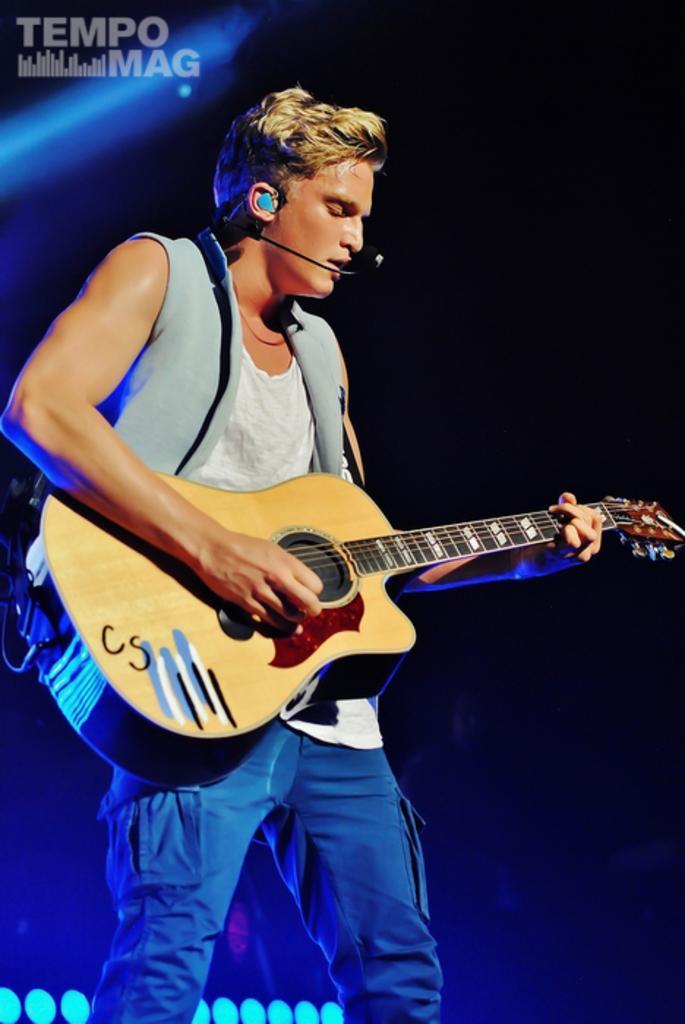Could you give a brief overview of what you see in this image? In this picture there is a man towards the left. He is playing a guitar and singing on a mike. The background is blue and black. 